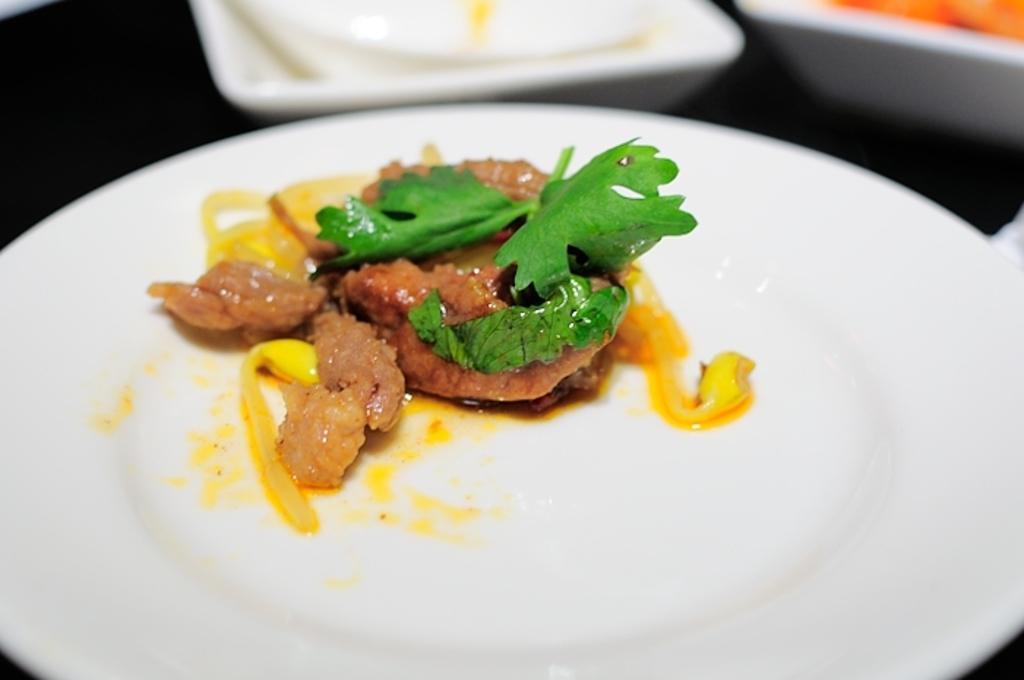What is on the plate that is visible in the image? There is a plate with food items in the image. What color is the plate in the image? The plate is white. What other tableware can be seen in the image? There are bowls in the background of the image. What color are the bowls in the image? The bowls are white. What is the tendency of the field in the image? There is no field present in the image; it features a plate with food items and white bowls in the background. 